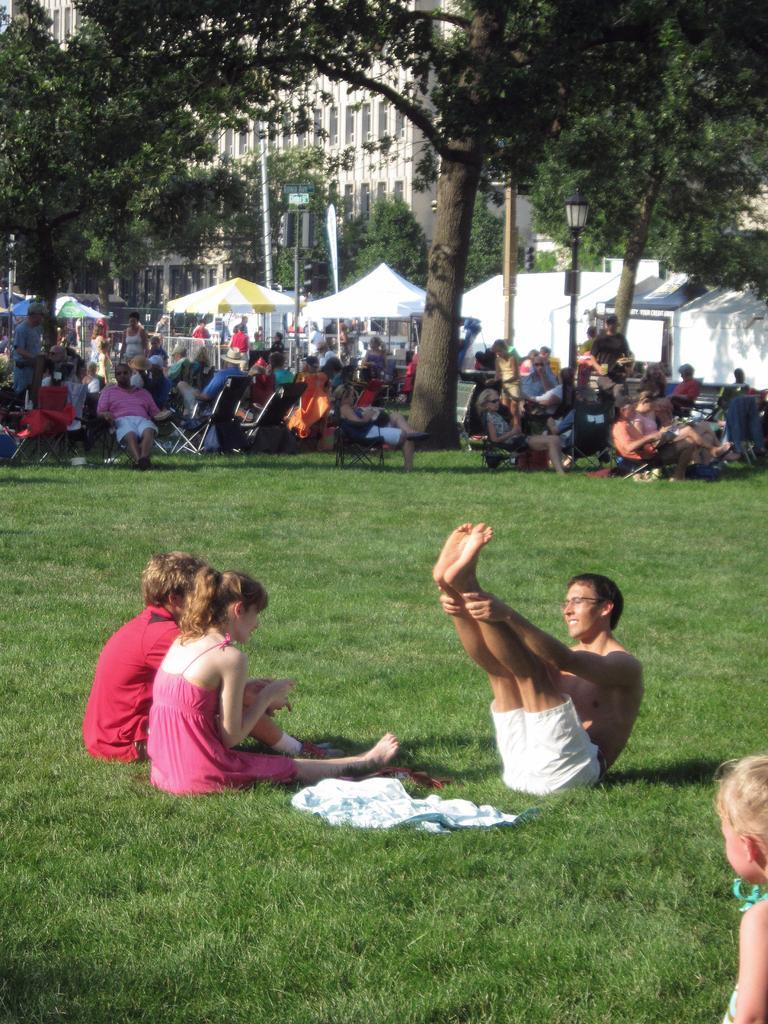Can you describe this image briefly? In the foreground we can three persons sitting on the grass. Here we can see a baby girl on the bottom right side. Here we can see a man and looks like he is doing an exercise. In the background, we can see a few persons sitting on the deck chairs. Here we can see the tents. Here we can see a decorative light pole on the right side. In the background, we can see the buildings and trees. 